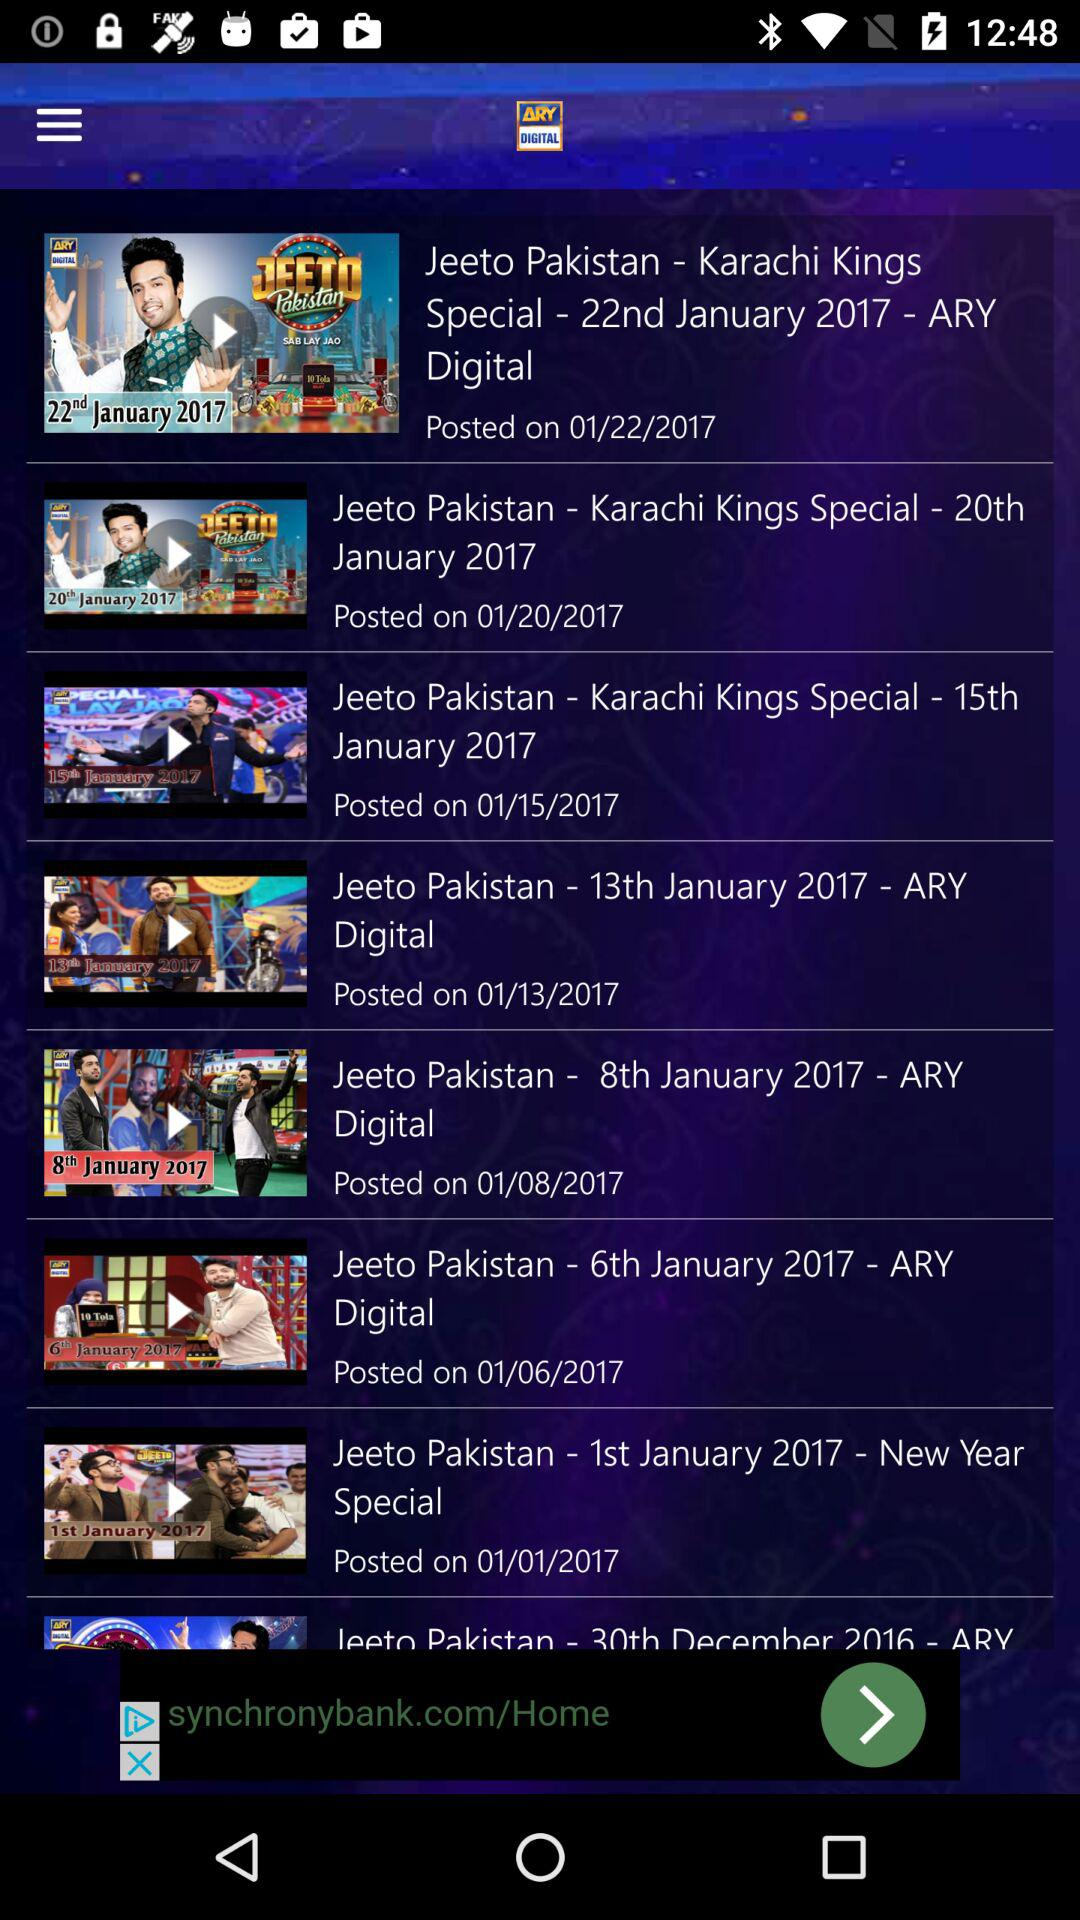When was jeeto pakistan posted?
When the provided information is insufficient, respond with <no answer>. <no answer> 